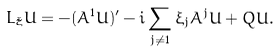Convert formula to latex. <formula><loc_0><loc_0><loc_500><loc_500>L _ { \tilde { \xi } } U = - ( { \bar { A } } ^ { 1 } U ) ^ { \prime } - i \sum _ { j \neq 1 } \xi _ { j } { \bar { A } } ^ { j } U + \bar { Q } U .</formula> 